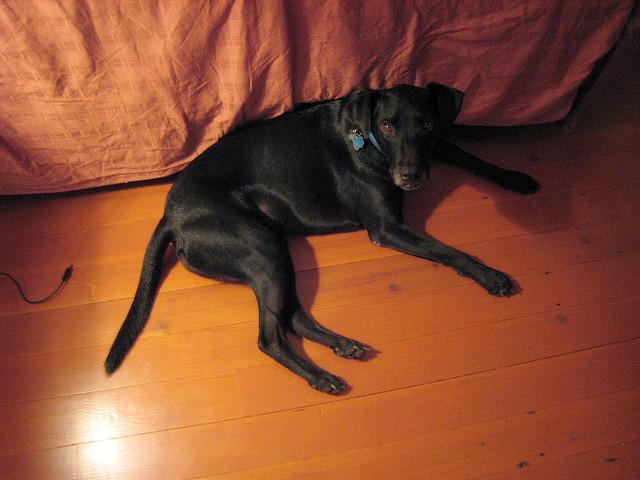What is the dog's tail pointing at?
Short answer required. Floor. Is the dog laying on wood flooring?
Be succinct. Yes. What color is the back paws?
Write a very short answer. Black. What shape is the dog's tag?
Give a very brief answer. Bone. 